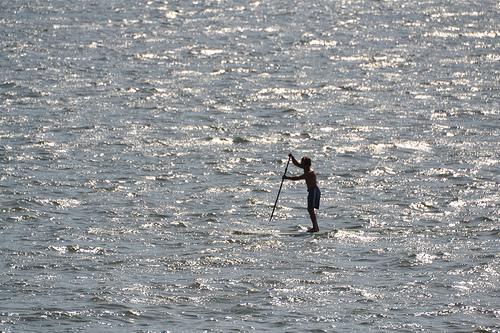How many paddleboarders are shown?
Give a very brief answer. 1. How many of the paddleboarder's arms are visible?
Give a very brief answer. 2. 